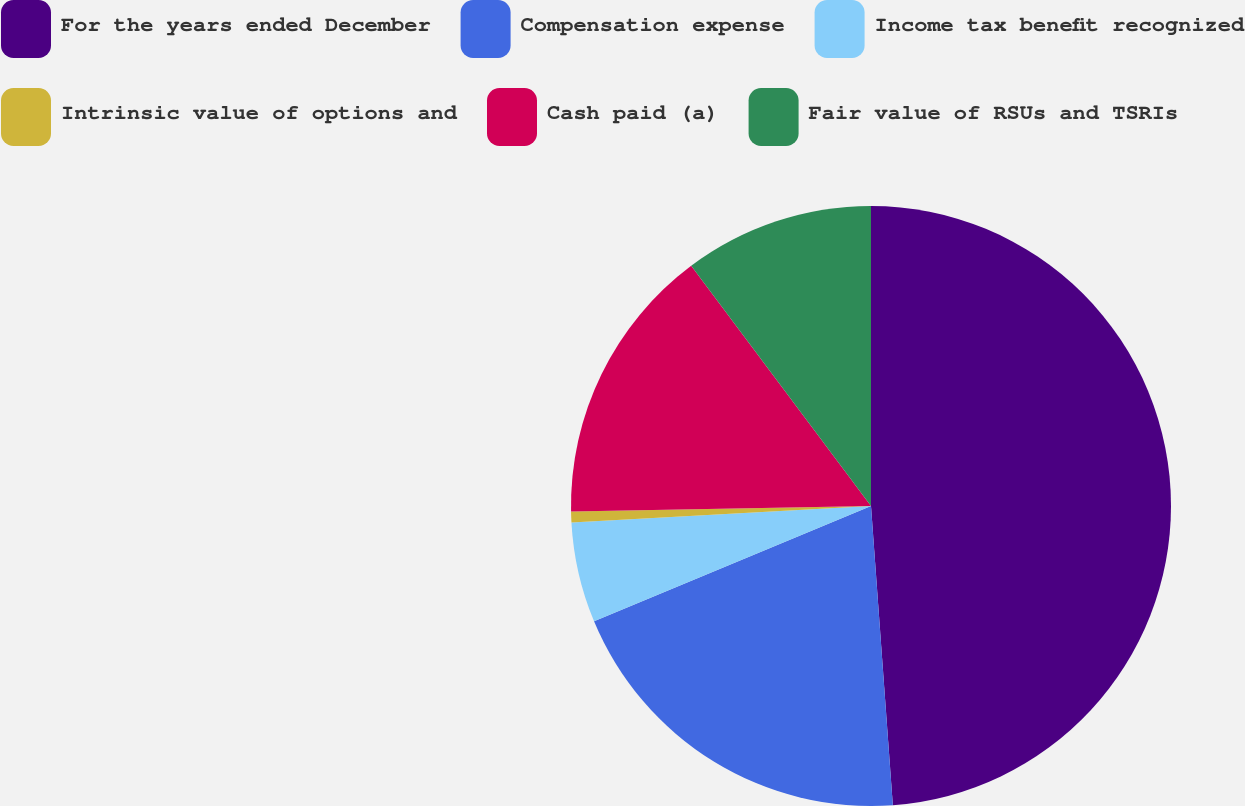<chart> <loc_0><loc_0><loc_500><loc_500><pie_chart><fcel>For the years ended December<fcel>Compensation expense<fcel>Income tax benefit recognized<fcel>Intrinsic value of options and<fcel>Cash paid (a)<fcel>Fair value of RSUs and TSRIs<nl><fcel>48.84%<fcel>19.88%<fcel>5.41%<fcel>0.58%<fcel>15.06%<fcel>10.23%<nl></chart> 